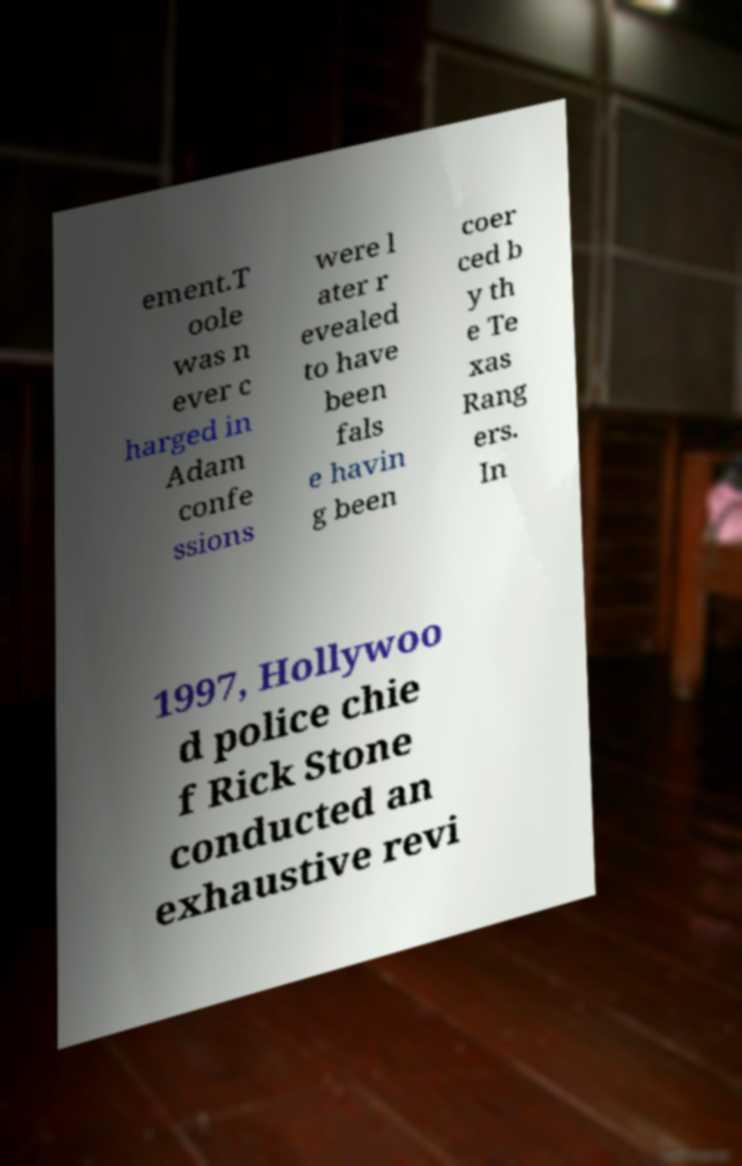Can you read and provide the text displayed in the image?This photo seems to have some interesting text. Can you extract and type it out for me? ement.T oole was n ever c harged in Adam confe ssions were l ater r evealed to have been fals e havin g been coer ced b y th e Te xas Rang ers. In 1997, Hollywoo d police chie f Rick Stone conducted an exhaustive revi 